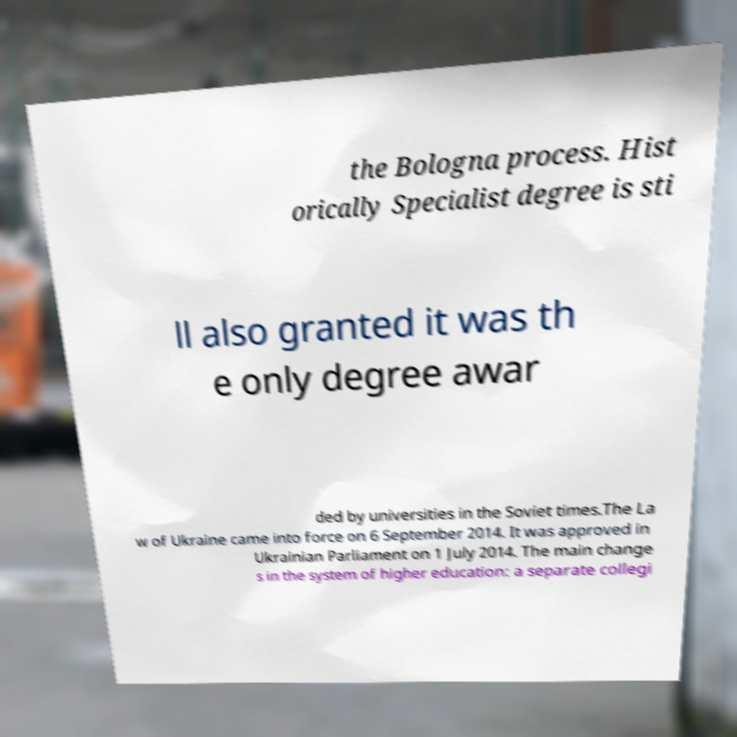What messages or text are displayed in this image? I need them in a readable, typed format. the Bologna process. Hist orically Specialist degree is sti ll also granted it was th e only degree awar ded by universities in the Soviet times.The La w of Ukraine came into force on 6 September 2014. It was approved in Ukrainian Parliament on 1 July 2014. The main change s in the system of higher education: a separate collegi 